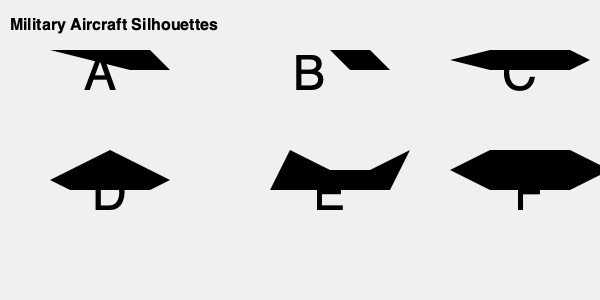Based on the silhouettes provided, which aircraft is most likely to be a stealth bomber designed for long-range missions and minimal radar detection? Explain your reasoning, considering the implications for counter-terrorism and national security strategies. To identify the stealth bomber designed for long-range missions and minimal radar detection, we need to analyze each silhouette and consider the characteristics of stealth aircraft:

1. Stealth aircraft typically have:
   - Sharp, angular designs to deflect radar waves
   - Smooth surfaces with minimal protrusions
   - Flying wing or blended wing-body configurations

2. Analyzing each silhouette:
   A: Appears to be a conventional fighter jet with a distinct fuselage and wings.
   B: Shows characteristics of a cargo or transport plane with a bulbous nose.
   C: Resembles a supersonic fighter jet with swept-back wings.
   D: Has a triangular shape, indicative of a delta-wing fighter.
   E: Displays a flying wing design with no distinct fuselage.
   F: Shows a blended wing-body configuration with smooth edges.

3. Based on these observations, silhouettes E and F are the most likely candidates for a stealth bomber.

4. Between E and F, silhouette F has a more pronounced blended wing-body design with smoother edges, which is optimal for radar deflection.

5. Implications for counter-terrorism and national security:
   - Stealth bombers can penetrate enemy air defenses undetected.
   - They can conduct long-range strike missions without requiring forward operating bases.
   - These aircraft enhance strategic deterrence capabilities.
   - They provide decision-makers with flexible options for addressing global threats.

Therefore, silhouette F is most likely to represent a stealth bomber designed for long-range missions and minimal radar detection.
Answer: Silhouette F 